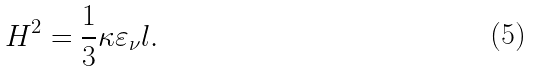Convert formula to latex. <formula><loc_0><loc_0><loc_500><loc_500>H ^ { 2 } = \frac { 1 } { 3 } \kappa \varepsilon _ { \nu } l .</formula> 